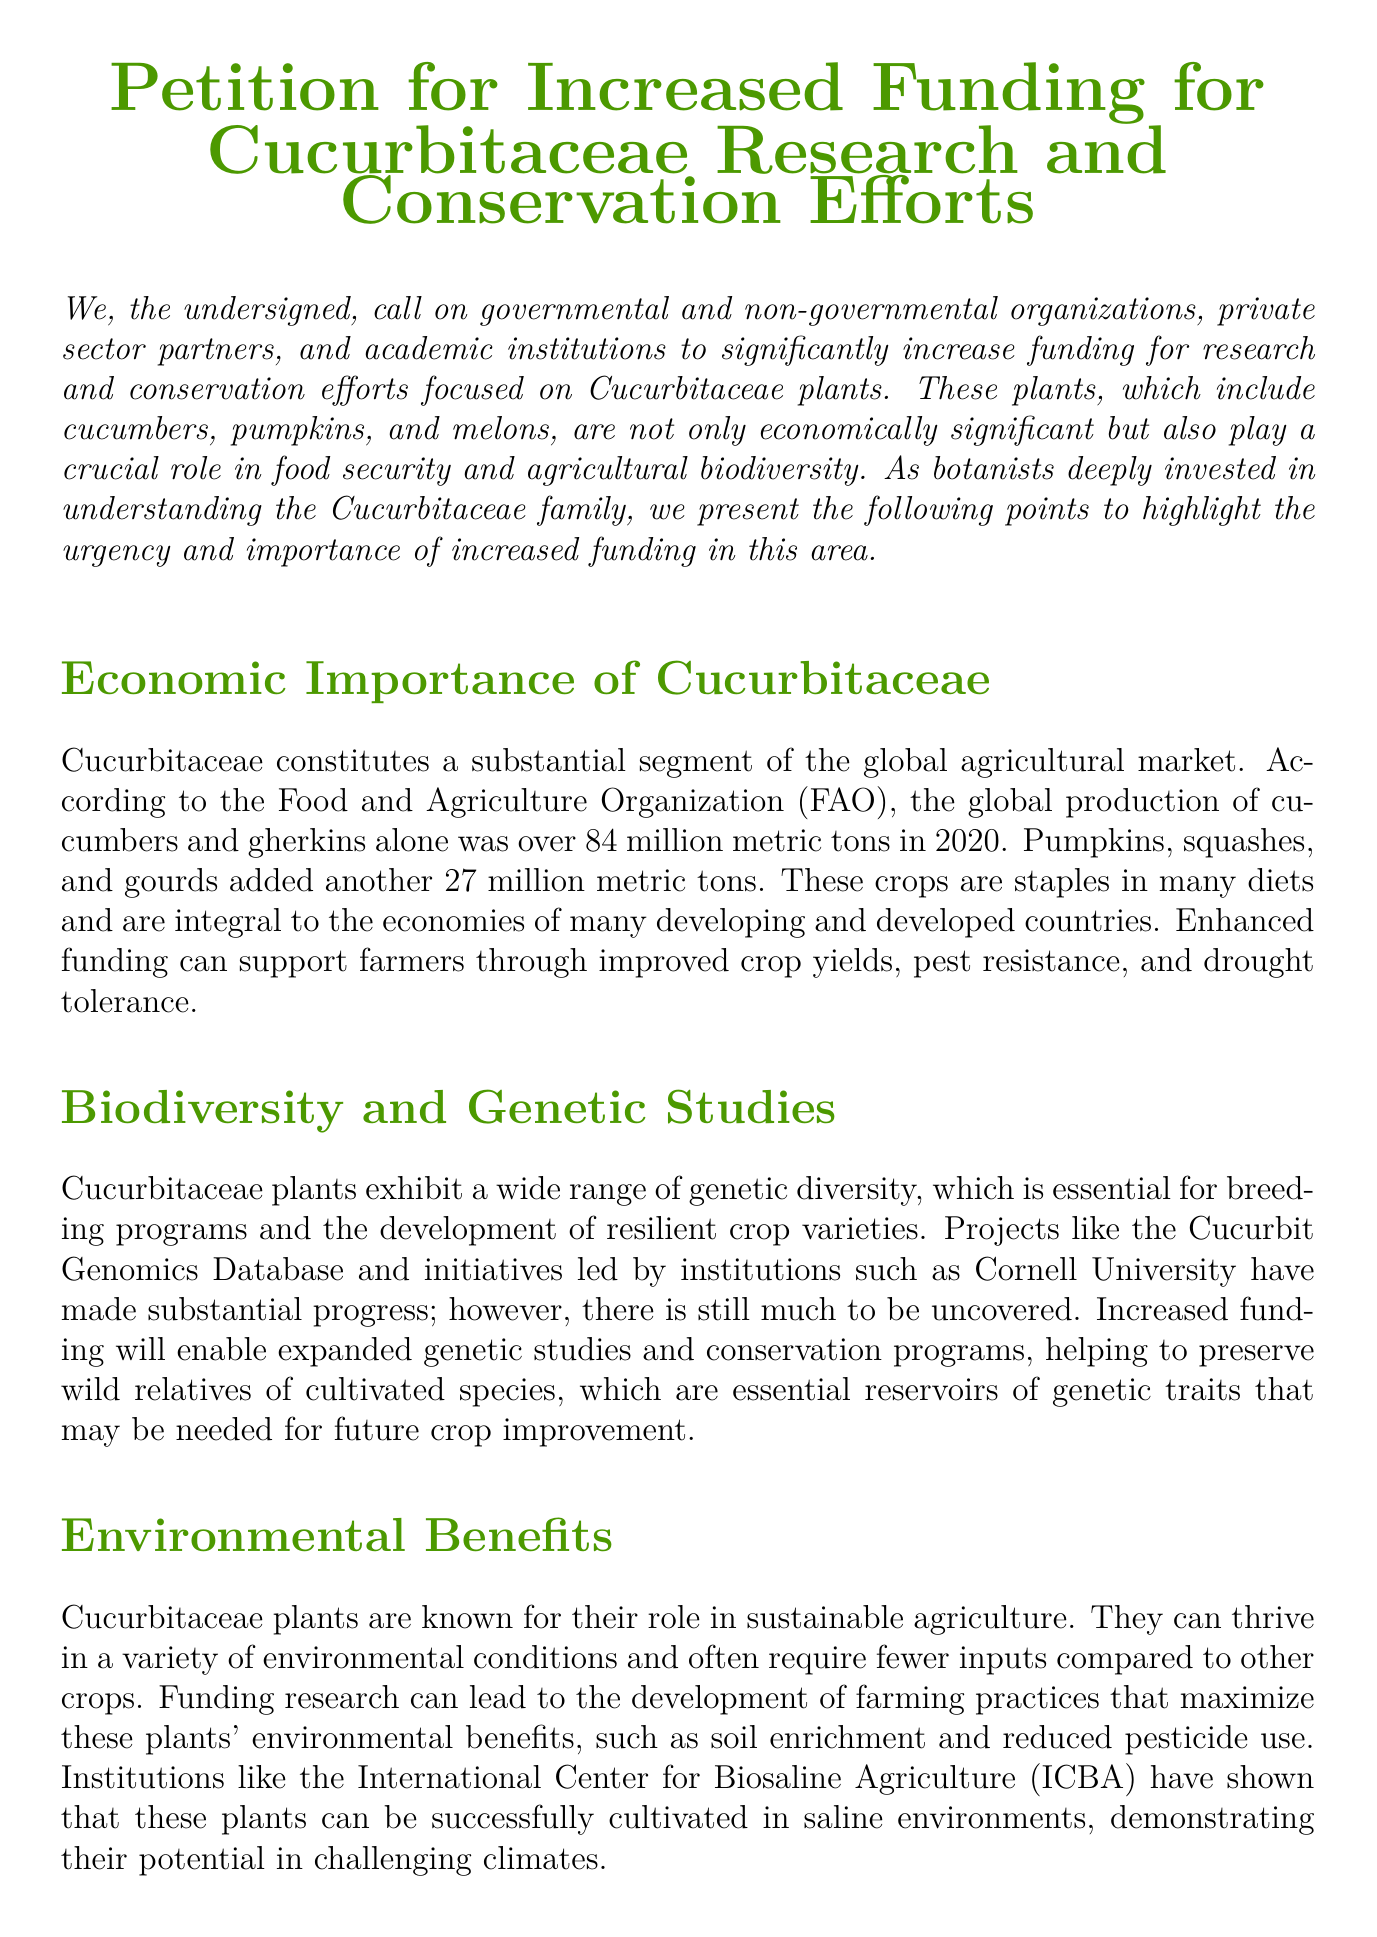What is being petitioned for? The document is a petition for increased funding for research and conservation efforts focused on Cucurbitaceae plants.
Answer: Increased funding for Cucurbitaceae research and conservation efforts How many metric tons of cucumbers and gherkins were produced globally in 2020? The document states that the global production of cucumbers and gherkins alone was over 84 million metric tons in 2020.
Answer: 84 million metric tons What crops are included in the Cucurbitaceae family mentioned in the petition? The petition specifically mentions cucumbers, pumpkins, and melons as examples of Cucurbitaceae plants.
Answer: Cucumbers, pumpkins, and melons Which organization is cited in the petition for its work related to genetic diversity? The document mentions the Cucurbit Genomics Database as a project that has made substantial progress in genetic studies.
Answer: Cucurbit Genomics Database What type of environmental challenges can Cucurbitaceae plants help address? The document highlights that these plants can be successfully cultivated in saline environments, demonstrating their potential in challenging climates.
Answer: Saline environments What health benefits are linked to Cucurbitaceae crops according to the document? The petition mentions improved heart health, diabetes management, and antioxidant properties as health benefits associated with Cucurbitaceae crops.
Answer: Improved heart health, diabetes management, antioxidant properties Who could benefit from comprehensive research funded by health-focused entities? The document states that comprehensive research could promote Cucurbitaceae plants as essential components of a balanced diet for the public.
Answer: The public What is the total metric tons production for pumpkins, squashes, and gourds in 2020? The petition states that pumpkins, squashes, and gourds added another 27 million metric tons of production in 2020.
Answer: 27 million metric tons 